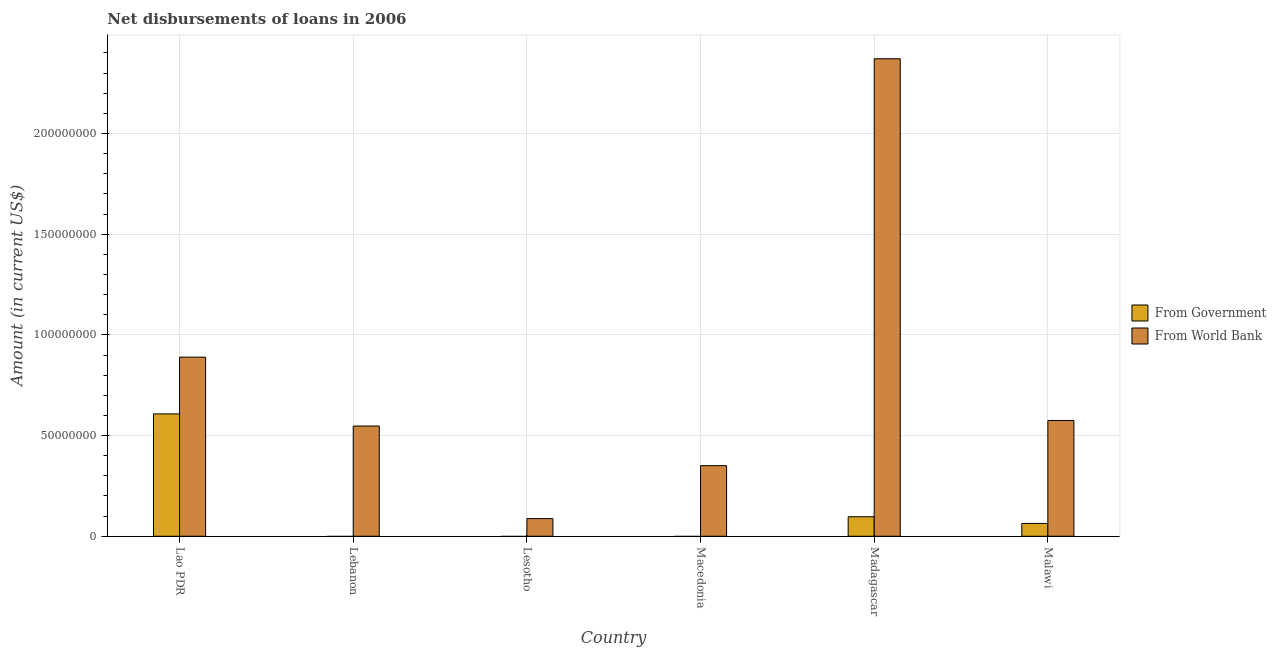Are the number of bars per tick equal to the number of legend labels?
Your response must be concise. No. How many bars are there on the 3rd tick from the right?
Give a very brief answer. 1. What is the label of the 3rd group of bars from the left?
Offer a very short reply. Lesotho. In how many cases, is the number of bars for a given country not equal to the number of legend labels?
Give a very brief answer. 3. What is the net disbursements of loan from government in Malawi?
Your answer should be compact. 6.36e+06. Across all countries, what is the maximum net disbursements of loan from government?
Provide a succinct answer. 6.08e+07. In which country was the net disbursements of loan from government maximum?
Offer a very short reply. Lao PDR. What is the total net disbursements of loan from government in the graph?
Keep it short and to the point. 7.68e+07. What is the difference between the net disbursements of loan from world bank in Macedonia and that in Madagascar?
Make the answer very short. -2.02e+08. What is the difference between the net disbursements of loan from government in Lebanon and the net disbursements of loan from world bank in Lao PDR?
Your answer should be compact. -8.89e+07. What is the average net disbursements of loan from government per country?
Give a very brief answer. 1.28e+07. What is the difference between the net disbursements of loan from government and net disbursements of loan from world bank in Madagascar?
Provide a succinct answer. -2.27e+08. In how many countries, is the net disbursements of loan from world bank greater than 130000000 US$?
Give a very brief answer. 1. What is the ratio of the net disbursements of loan from world bank in Lao PDR to that in Madagascar?
Provide a succinct answer. 0.38. Is the net disbursements of loan from world bank in Lao PDR less than that in Lebanon?
Your answer should be compact. No. Is the difference between the net disbursements of loan from government in Lao PDR and Malawi greater than the difference between the net disbursements of loan from world bank in Lao PDR and Malawi?
Keep it short and to the point. Yes. What is the difference between the highest and the second highest net disbursements of loan from government?
Offer a very short reply. 5.11e+07. What is the difference between the highest and the lowest net disbursements of loan from world bank?
Ensure brevity in your answer.  2.28e+08. In how many countries, is the net disbursements of loan from world bank greater than the average net disbursements of loan from world bank taken over all countries?
Provide a succinct answer. 2. How many bars are there?
Offer a terse response. 9. What is the difference between two consecutive major ticks on the Y-axis?
Offer a terse response. 5.00e+07. Are the values on the major ticks of Y-axis written in scientific E-notation?
Provide a short and direct response. No. Does the graph contain any zero values?
Give a very brief answer. Yes. Where does the legend appear in the graph?
Offer a very short reply. Center right. How many legend labels are there?
Your response must be concise. 2. How are the legend labels stacked?
Your answer should be very brief. Vertical. What is the title of the graph?
Your response must be concise. Net disbursements of loans in 2006. Does "Electricity and heat production" appear as one of the legend labels in the graph?
Provide a succinct answer. No. What is the Amount (in current US$) of From Government in Lao PDR?
Your answer should be compact. 6.08e+07. What is the Amount (in current US$) of From World Bank in Lao PDR?
Your answer should be very brief. 8.89e+07. What is the Amount (in current US$) of From Government in Lebanon?
Ensure brevity in your answer.  0. What is the Amount (in current US$) in From World Bank in Lebanon?
Offer a very short reply. 5.47e+07. What is the Amount (in current US$) of From Government in Lesotho?
Keep it short and to the point. 0. What is the Amount (in current US$) in From World Bank in Lesotho?
Keep it short and to the point. 8.76e+06. What is the Amount (in current US$) in From Government in Macedonia?
Your answer should be compact. 0. What is the Amount (in current US$) in From World Bank in Macedonia?
Make the answer very short. 3.51e+07. What is the Amount (in current US$) of From Government in Madagascar?
Make the answer very short. 9.69e+06. What is the Amount (in current US$) in From World Bank in Madagascar?
Your answer should be compact. 2.37e+08. What is the Amount (in current US$) of From Government in Malawi?
Your answer should be very brief. 6.36e+06. What is the Amount (in current US$) in From World Bank in Malawi?
Offer a very short reply. 5.75e+07. Across all countries, what is the maximum Amount (in current US$) in From Government?
Keep it short and to the point. 6.08e+07. Across all countries, what is the maximum Amount (in current US$) in From World Bank?
Provide a short and direct response. 2.37e+08. Across all countries, what is the minimum Amount (in current US$) of From Government?
Ensure brevity in your answer.  0. Across all countries, what is the minimum Amount (in current US$) of From World Bank?
Your answer should be very brief. 8.76e+06. What is the total Amount (in current US$) of From Government in the graph?
Offer a very short reply. 7.68e+07. What is the total Amount (in current US$) in From World Bank in the graph?
Offer a terse response. 4.82e+08. What is the difference between the Amount (in current US$) of From World Bank in Lao PDR and that in Lebanon?
Offer a terse response. 3.42e+07. What is the difference between the Amount (in current US$) in From World Bank in Lao PDR and that in Lesotho?
Give a very brief answer. 8.02e+07. What is the difference between the Amount (in current US$) of From World Bank in Lao PDR and that in Macedonia?
Give a very brief answer. 5.39e+07. What is the difference between the Amount (in current US$) of From Government in Lao PDR and that in Madagascar?
Your response must be concise. 5.11e+07. What is the difference between the Amount (in current US$) in From World Bank in Lao PDR and that in Madagascar?
Offer a very short reply. -1.48e+08. What is the difference between the Amount (in current US$) of From Government in Lao PDR and that in Malawi?
Offer a terse response. 5.44e+07. What is the difference between the Amount (in current US$) in From World Bank in Lao PDR and that in Malawi?
Your answer should be compact. 3.14e+07. What is the difference between the Amount (in current US$) in From World Bank in Lebanon and that in Lesotho?
Your response must be concise. 4.60e+07. What is the difference between the Amount (in current US$) in From World Bank in Lebanon and that in Macedonia?
Provide a succinct answer. 1.97e+07. What is the difference between the Amount (in current US$) in From World Bank in Lebanon and that in Madagascar?
Your response must be concise. -1.82e+08. What is the difference between the Amount (in current US$) in From World Bank in Lebanon and that in Malawi?
Ensure brevity in your answer.  -2.76e+06. What is the difference between the Amount (in current US$) in From World Bank in Lesotho and that in Macedonia?
Your answer should be very brief. -2.63e+07. What is the difference between the Amount (in current US$) in From World Bank in Lesotho and that in Madagascar?
Ensure brevity in your answer.  -2.28e+08. What is the difference between the Amount (in current US$) of From World Bank in Lesotho and that in Malawi?
Offer a very short reply. -4.87e+07. What is the difference between the Amount (in current US$) in From World Bank in Macedonia and that in Madagascar?
Your response must be concise. -2.02e+08. What is the difference between the Amount (in current US$) of From World Bank in Macedonia and that in Malawi?
Provide a short and direct response. -2.24e+07. What is the difference between the Amount (in current US$) of From Government in Madagascar and that in Malawi?
Ensure brevity in your answer.  3.33e+06. What is the difference between the Amount (in current US$) of From World Bank in Madagascar and that in Malawi?
Offer a very short reply. 1.80e+08. What is the difference between the Amount (in current US$) of From Government in Lao PDR and the Amount (in current US$) of From World Bank in Lebanon?
Your response must be concise. 6.02e+06. What is the difference between the Amount (in current US$) of From Government in Lao PDR and the Amount (in current US$) of From World Bank in Lesotho?
Provide a short and direct response. 5.20e+07. What is the difference between the Amount (in current US$) of From Government in Lao PDR and the Amount (in current US$) of From World Bank in Macedonia?
Provide a succinct answer. 2.57e+07. What is the difference between the Amount (in current US$) in From Government in Lao PDR and the Amount (in current US$) in From World Bank in Madagascar?
Provide a succinct answer. -1.76e+08. What is the difference between the Amount (in current US$) of From Government in Lao PDR and the Amount (in current US$) of From World Bank in Malawi?
Your answer should be very brief. 3.27e+06. What is the difference between the Amount (in current US$) in From Government in Madagascar and the Amount (in current US$) in From World Bank in Malawi?
Give a very brief answer. -4.78e+07. What is the average Amount (in current US$) in From Government per country?
Your answer should be compact. 1.28e+07. What is the average Amount (in current US$) of From World Bank per country?
Keep it short and to the point. 8.03e+07. What is the difference between the Amount (in current US$) in From Government and Amount (in current US$) in From World Bank in Lao PDR?
Offer a terse response. -2.82e+07. What is the difference between the Amount (in current US$) in From Government and Amount (in current US$) in From World Bank in Madagascar?
Provide a succinct answer. -2.27e+08. What is the difference between the Amount (in current US$) of From Government and Amount (in current US$) of From World Bank in Malawi?
Your response must be concise. -5.11e+07. What is the ratio of the Amount (in current US$) of From World Bank in Lao PDR to that in Lebanon?
Provide a succinct answer. 1.62. What is the ratio of the Amount (in current US$) in From World Bank in Lao PDR to that in Lesotho?
Give a very brief answer. 10.15. What is the ratio of the Amount (in current US$) of From World Bank in Lao PDR to that in Macedonia?
Ensure brevity in your answer.  2.54. What is the ratio of the Amount (in current US$) in From Government in Lao PDR to that in Madagascar?
Offer a terse response. 6.27. What is the ratio of the Amount (in current US$) of From World Bank in Lao PDR to that in Madagascar?
Provide a succinct answer. 0.38. What is the ratio of the Amount (in current US$) of From Government in Lao PDR to that in Malawi?
Your answer should be very brief. 9.56. What is the ratio of the Amount (in current US$) of From World Bank in Lao PDR to that in Malawi?
Your answer should be compact. 1.55. What is the ratio of the Amount (in current US$) of From World Bank in Lebanon to that in Lesotho?
Offer a very short reply. 6.25. What is the ratio of the Amount (in current US$) of From World Bank in Lebanon to that in Macedonia?
Give a very brief answer. 1.56. What is the ratio of the Amount (in current US$) of From World Bank in Lebanon to that in Madagascar?
Offer a very short reply. 0.23. What is the ratio of the Amount (in current US$) in From World Bank in Lebanon to that in Malawi?
Give a very brief answer. 0.95. What is the ratio of the Amount (in current US$) of From World Bank in Lesotho to that in Macedonia?
Your response must be concise. 0.25. What is the ratio of the Amount (in current US$) of From World Bank in Lesotho to that in Madagascar?
Offer a terse response. 0.04. What is the ratio of the Amount (in current US$) of From World Bank in Lesotho to that in Malawi?
Offer a very short reply. 0.15. What is the ratio of the Amount (in current US$) in From World Bank in Macedonia to that in Madagascar?
Keep it short and to the point. 0.15. What is the ratio of the Amount (in current US$) in From World Bank in Macedonia to that in Malawi?
Ensure brevity in your answer.  0.61. What is the ratio of the Amount (in current US$) in From Government in Madagascar to that in Malawi?
Your answer should be very brief. 1.52. What is the ratio of the Amount (in current US$) of From World Bank in Madagascar to that in Malawi?
Make the answer very short. 4.12. What is the difference between the highest and the second highest Amount (in current US$) in From Government?
Your answer should be very brief. 5.11e+07. What is the difference between the highest and the second highest Amount (in current US$) of From World Bank?
Your response must be concise. 1.48e+08. What is the difference between the highest and the lowest Amount (in current US$) in From Government?
Provide a succinct answer. 6.08e+07. What is the difference between the highest and the lowest Amount (in current US$) of From World Bank?
Your answer should be compact. 2.28e+08. 